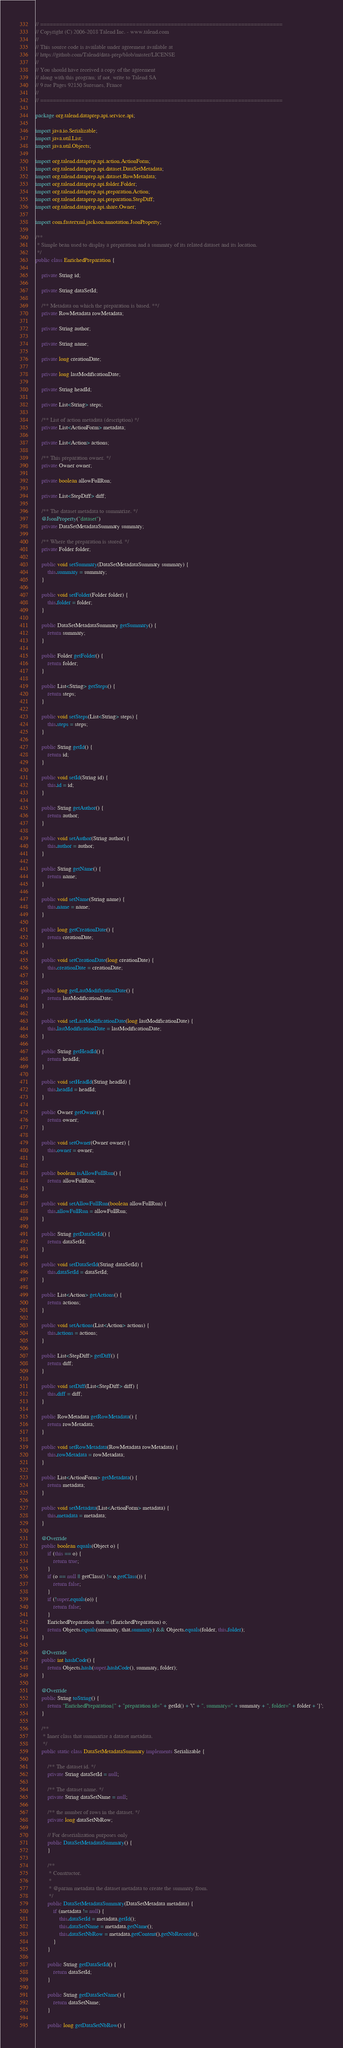Convert code to text. <code><loc_0><loc_0><loc_500><loc_500><_Java_>// ============================================================================
// Copyright (C) 2006-2018 Talend Inc. - www.talend.com
//
// This source code is available under agreement available at
// https://github.com/Talend/data-prep/blob/master/LICENSE
//
// You should have received a copy of the agreement
// along with this program; if not, write to Talend SA
// 9 rue Pages 92150 Suresnes, France
//
// ============================================================================

package org.talend.dataprep.api.service.api;

import java.io.Serializable;
import java.util.List;
import java.util.Objects;

import org.talend.dataprep.api.action.ActionForm;
import org.talend.dataprep.api.dataset.DataSetMetadata;
import org.talend.dataprep.api.dataset.RowMetadata;
import org.talend.dataprep.api.folder.Folder;
import org.talend.dataprep.api.preparation.Action;
import org.talend.dataprep.api.preparation.StepDiff;
import org.talend.dataprep.api.share.Owner;

import com.fasterxml.jackson.annotation.JsonProperty;

/**
 * Simple bean used to display a preparation and a summary of its related dataset and its location.
 */
public class EnrichedPreparation {

    private String id;

    private String dataSetId;

    /** Metadata on which the preparation is based. **/
    private RowMetadata rowMetadata;

    private String author;

    private String name;

    private long creationDate;

    private long lastModificationDate;

    private String headId;

    private List<String> steps;

    /** List of action metadata (description) */
    private List<ActionForm> metadata;

    private List<Action> actions;

    /** This preparation owner. */
    private Owner owner;

    private boolean allowFullRun;

    private List<StepDiff> diff;

    /** The dataset metadata to summarize. */
    @JsonProperty("dataset")
    private DataSetMetadataSummary summary;

    /** Where the preparation is stored. */
    private Folder folder;

    public void setSummary(DataSetMetadataSummary summary) {
        this.summary = summary;
    }

    public void setFolder(Folder folder) {
        this.folder = folder;
    }

    public DataSetMetadataSummary getSummary() {
        return summary;
    }

    public Folder getFolder() {
        return folder;
    }

    public List<String> getSteps() {
        return steps;
    }

    public void setSteps(List<String> steps) {
        this.steps = steps;
    }

    public String getId() {
        return id;
    }

    public void setId(String id) {
        this.id = id;
    }

    public String getAuthor() {
        return author;
    }

    public void setAuthor(String author) {
        this.author = author;
    }

    public String getName() {
        return name;
    }

    public void setName(String name) {
        this.name = name;
    }

    public long getCreationDate() {
        return creationDate;
    }

    public void setCreationDate(long creationDate) {
        this.creationDate = creationDate;
    }

    public long getLastModificationDate() {
        return lastModificationDate;
    }

    public void setLastModificationDate(long lastModificationDate) {
        this.lastModificationDate = lastModificationDate;
    }

    public String getHeadId() {
        return headId;
    }

    public void setHeadId(String headId) {
        this.headId = headId;
    }

    public Owner getOwner() {
        return owner;
    }

    public void setOwner(Owner owner) {
        this.owner = owner;
    }

    public boolean isAllowFullRun() {
        return allowFullRun;
    }

    public void setAllowFullRun(boolean allowFullRun) {
        this.allowFullRun = allowFullRun;
    }

    public String getDataSetId() {
        return dataSetId;
    }

    public void setDataSetId(String dataSetId) {
        this.dataSetId = dataSetId;
    }

    public List<Action> getActions() {
        return actions;
    }

    public void setActions(List<Action> actions) {
        this.actions = actions;
    }

    public List<StepDiff> getDiff() {
        return diff;
    }

    public void setDiff(List<StepDiff> diff) {
        this.diff = diff;
    }

    public RowMetadata getRowMetadata() {
        return rowMetadata;
    }

    public void setRowMetadata(RowMetadata rowMetadata) {
        this.rowMetadata = rowMetadata;
    }

    public List<ActionForm> getMetadata() {
        return metadata;
    }

    public void setMetadata(List<ActionForm> metadata) {
        this.metadata = metadata;
    }

    @Override
    public boolean equals(Object o) {
        if (this == o) {
            return true;
        }
        if (o == null || getClass() != o.getClass()) {
            return false;
        }
        if (!super.equals(o)) {
            return false;
        }
        EnrichedPreparation that = (EnrichedPreparation) o;
        return Objects.equals(summary, that.summary) && Objects.equals(folder, this.folder);
    }

    @Override
    public int hashCode() {
        return Objects.hash(super.hashCode(), summary, folder);
    }

    @Override
    public String toString() {
        return "EnrichedPreparation{" + "preparation id=" + getId() + '\'' + ", summary=" + summary + ", folder=" + folder + '}';
    }

    /**
     * Inner class that summarize a dataset metadata.
     */
    public static class DataSetMetadataSummary implements Serializable {

        /** The dataset id. */
        private String dataSetId = null;

        /** The dataset name. */
        private String dataSetName = null;

        /** the number of rows in the dataset. */
        private long dataSetNbRow;

        // For deserialization purposes only
        public DataSetMetadataSummary() {
        }

        /**
         * Constructor.
         *
         * @param metadata the dataset metadata to create the summary from.
         */
        public DataSetMetadataSummary(DataSetMetadata metadata) {
            if (metadata != null) {
                this.dataSetId = metadata.getId();
                this.dataSetName = metadata.getName();
                this.dataSetNbRow = metadata.getContent().getNbRecords();
            }
        }

        public String getDataSetId() {
            return dataSetId;
        }

        public String getDataSetName() {
            return dataSetName;
        }

        public long getDataSetNbRow() {</code> 